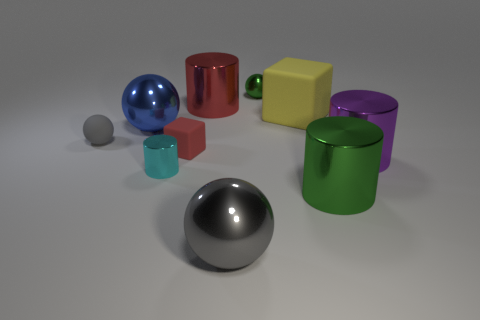Subtract all red cylinders. Subtract all purple balls. How many cylinders are left? 3 Subtract all cylinders. How many objects are left? 6 Subtract 0 yellow cylinders. How many objects are left? 10 Subtract all big purple shiny cylinders. Subtract all tiny blocks. How many objects are left? 8 Add 4 big green metal things. How many big green metal things are left? 5 Add 7 blue shiny spheres. How many blue shiny spheres exist? 8 